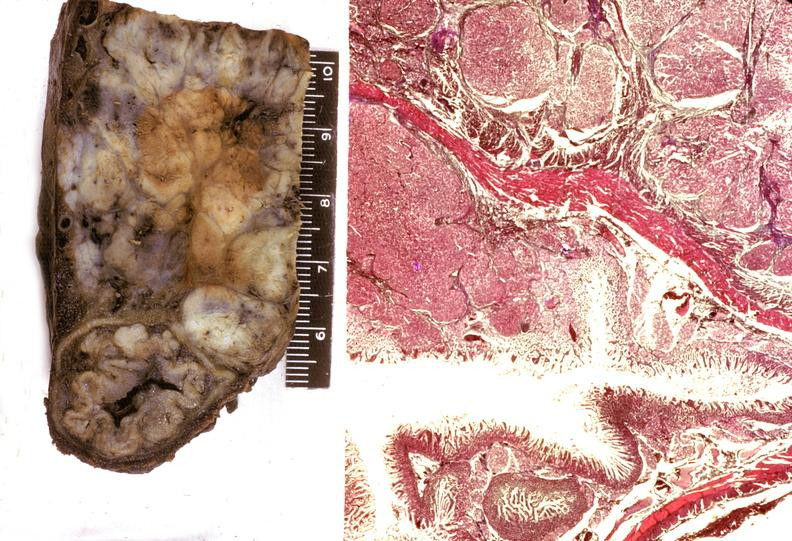what is present?
Answer the question using a single word or phrase. Pancreas 